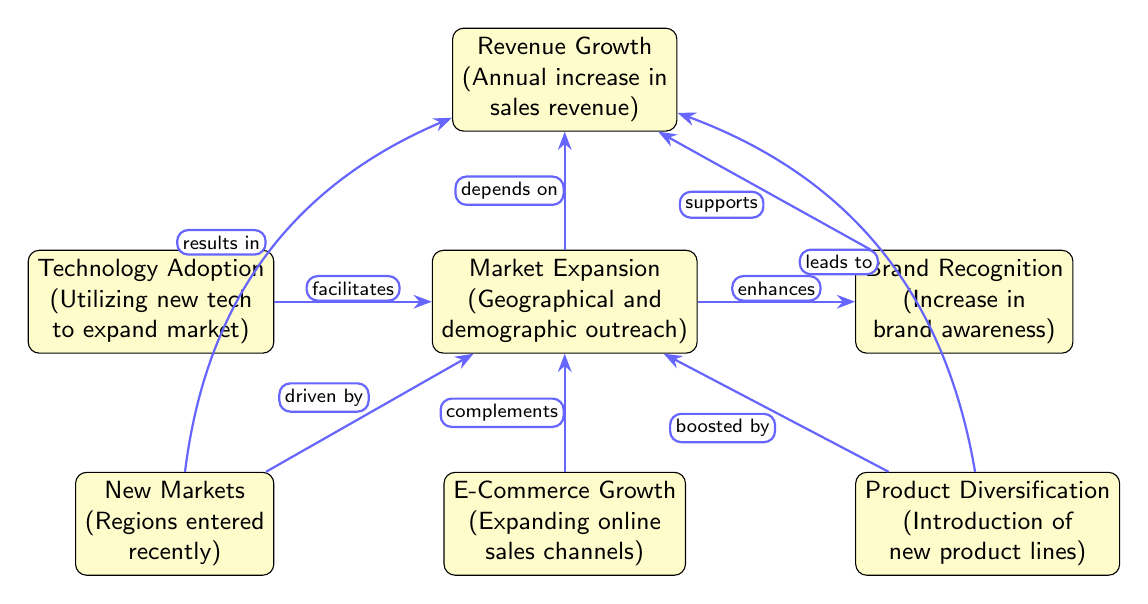What is the primary focus of the diagram? The diagram primarily focuses on analyzing the relationship between Revenue Growth and Market Expansion over the last decade. It visually represents how various factors contribute to revenue growth along with the impacts of market expansion.
Answer: Revenue Growth vs. Market Expansion How many main nodes are there in the diagram? The diagram contains a total of seven main nodes, including the primary concepts of Revenue Growth and Market Expansion, along with their contributing factors.
Answer: 7 What does Technology Adoption facilitate? According to the diagram, Technology Adoption facilitates Market Expansion, suggesting that adopting new technologies can help reach broader markets.
Answer: Market Expansion Which node is directly connected to Market Expansion by the edge labeled "depends on"? The edge labeled "depends on" connects Market Expansion to Revenue Growth, indicating that Revenue Growth is contingent upon the effectiveness of Market Expansion strategies.
Answer: Revenue Growth What are the two factors directly linked to Market Expansion that can lead to Revenue Growth? The two factors linked to Market Expansion that can lead to Revenue Growth are New Markets and Product Diversification. Both factors are mentioned in the diagram as ways to enhance overall revenue.
Answer: New Markets, Product Diversification Explain how Brand Recognition supports Revenue Growth. Brand Recognition enhances Market Expansion, and since Market Expansion depends on challenges related to accessing new customers, the increase in brand awareness can lead to improved sales, thereby supporting Revenue Growth. Hence, the path is: Market Expansion → Brand Recognition → Revenue Growth.
Answer: Brand Recognition Which component is complemented by E-Commerce Growth? The diagram indicates that E-Commerce Growth complements Market Expansion, suggesting that increasing online sales channels can further enhance efforts to expand into broader geographical and demographic markets.
Answer: Market Expansion 